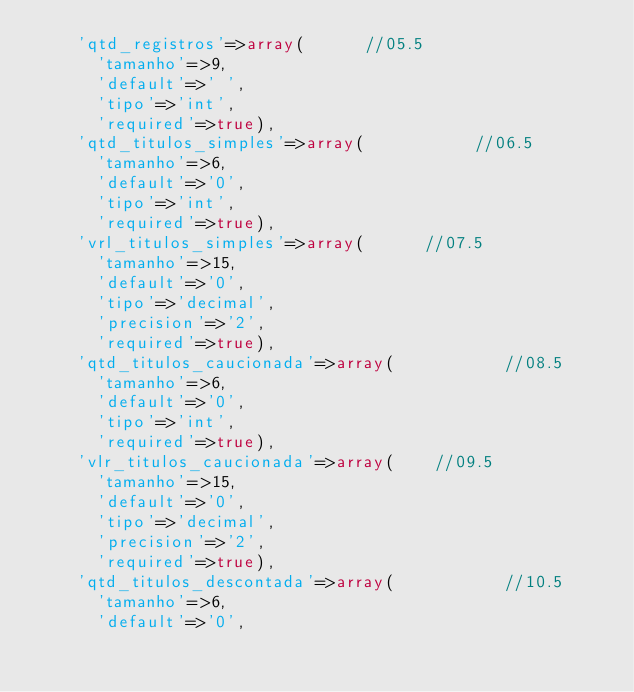Convert code to text. <code><loc_0><loc_0><loc_500><loc_500><_PHP_>		'qtd_registros'=>array(      //05.5
			'tamanho'=>9,
			'default'=>' ',
			'tipo'=>'int',
			'required'=>true),
		'qtd_titulos_simples'=>array(           //06.5
			'tamanho'=>6,
			'default'=>'0',
			'tipo'=>'int',
			'required'=>true),
		'vrl_titulos_simples'=>array(      //07.5
			'tamanho'=>15,
			'default'=>'0',
			'tipo'=>'decimal',
			'precision'=>'2',
			'required'=>true),
		'qtd_titulos_caucionada'=>array(           //08.5
			'tamanho'=>6,
			'default'=>'0',
			'tipo'=>'int',
			'required'=>true),
		'vlr_titulos_caucionada'=>array(    //09.5
			'tamanho'=>15,
			'default'=>'0',
			'tipo'=>'decimal',
			'precision'=>'2',
			'required'=>true),
		'qtd_titulos_descontada'=>array(           //10.5
			'tamanho'=>6,
			'default'=>'0',</code> 